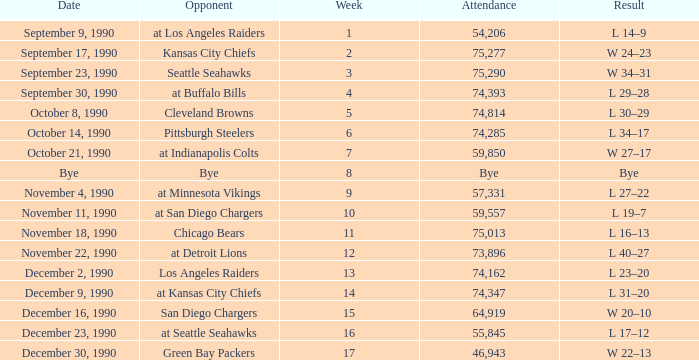Write the full table. {'header': ['Date', 'Opponent', 'Week', 'Attendance', 'Result'], 'rows': [['September 9, 1990', 'at Los Angeles Raiders', '1', '54,206', 'L 14–9'], ['September 17, 1990', 'Kansas City Chiefs', '2', '75,277', 'W 24–23'], ['September 23, 1990', 'Seattle Seahawks', '3', '75,290', 'W 34–31'], ['September 30, 1990', 'at Buffalo Bills', '4', '74,393', 'L 29–28'], ['October 8, 1990', 'Cleveland Browns', '5', '74,814', 'L 30–29'], ['October 14, 1990', 'Pittsburgh Steelers', '6', '74,285', 'L 34–17'], ['October 21, 1990', 'at Indianapolis Colts', '7', '59,850', 'W 27–17'], ['Bye', 'Bye', '8', 'Bye', 'Bye'], ['November 4, 1990', 'at Minnesota Vikings', '9', '57,331', 'L 27–22'], ['November 11, 1990', 'at San Diego Chargers', '10', '59,557', 'L 19–7'], ['November 18, 1990', 'Chicago Bears', '11', '75,013', 'L 16–13'], ['November 22, 1990', 'at Detroit Lions', '12', '73,896', 'L 40–27'], ['December 2, 1990', 'Los Angeles Raiders', '13', '74,162', 'L 23–20'], ['December 9, 1990', 'at Kansas City Chiefs', '14', '74,347', 'L 31–20'], ['December 16, 1990', 'San Diego Chargers', '15', '64,919', 'W 20–10'], ['December 23, 1990', 'at Seattle Seahawks', '16', '55,845', 'L 17–12'], ['December 30, 1990', 'Green Bay Packers', '17', '46,943', 'W 22–13']]} Who is the opponent when the attendance is 57,331? At minnesota vikings. 